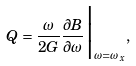Convert formula to latex. <formula><loc_0><loc_0><loc_500><loc_500>Q = \frac { \omega } { 2 G } \frac { \partial B } { \partial \omega } \Big { | } _ { \omega = \omega _ { x } } ,</formula> 